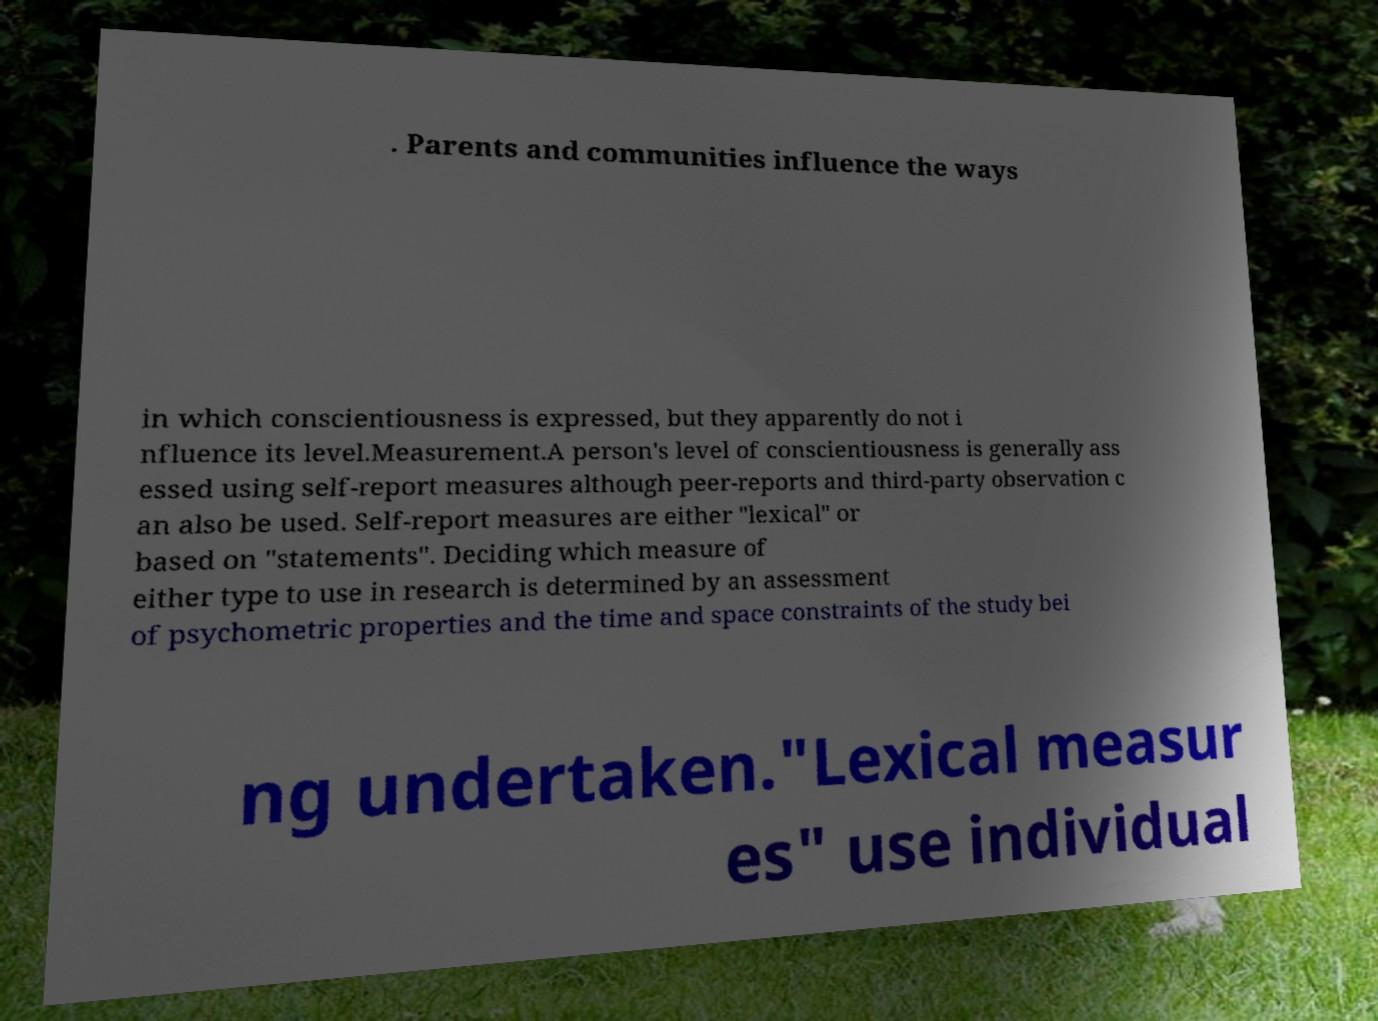Could you assist in decoding the text presented in this image and type it out clearly? . Parents and communities influence the ways in which conscientiousness is expressed, but they apparently do not i nfluence its level.Measurement.A person's level of conscientiousness is generally ass essed using self-report measures although peer-reports and third-party observation c an also be used. Self-report measures are either "lexical" or based on "statements". Deciding which measure of either type to use in research is determined by an assessment of psychometric properties and the time and space constraints of the study bei ng undertaken."Lexical measur es" use individual 